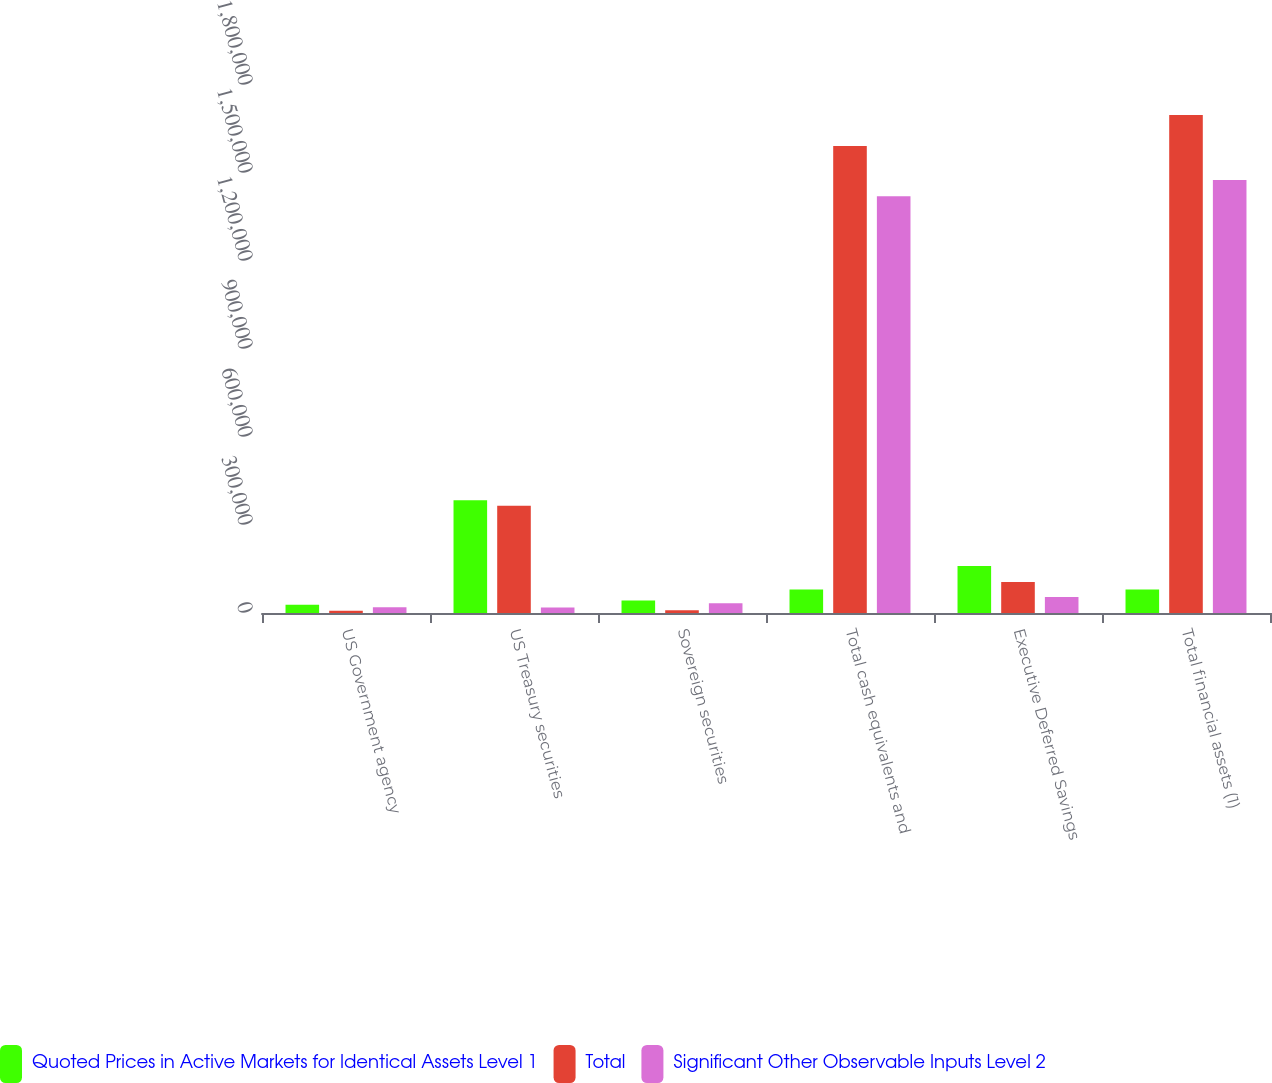<chart> <loc_0><loc_0><loc_500><loc_500><stacked_bar_chart><ecel><fcel>US Government agency<fcel>US Treasury securities<fcel>Sovereign securities<fcel>Total cash equivalents and<fcel>Executive Deferred Savings<fcel>Total financial assets (1)<nl><fcel>Quoted Prices in Active Markets for Identical Assets Level 1<fcel>28000<fcel>384400<fcel>42264<fcel>79997.5<fcel>159995<fcel>79997.5<nl><fcel>Total<fcel>8000<fcel>365401<fcel>9253<fcel>1.59201e+06<fcel>105311<fcel>1.69732e+06<nl><fcel>Significant Other Observable Inputs Level 2<fcel>20000<fcel>18999<fcel>33011<fcel>1.4204e+06<fcel>54684<fcel>1.47575e+06<nl></chart> 